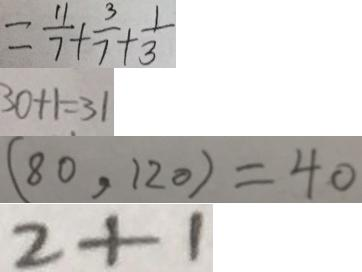<formula> <loc_0><loc_0><loc_500><loc_500>= \frac { 1 1 } { 7 } + \frac { 3 } { 7 } + \frac { 1 } { 3 } 
 3 0 + 1 = 3 1 
 ( 8 0 , 1 2 0 ) = 4 0 
 2 + 1</formula> 